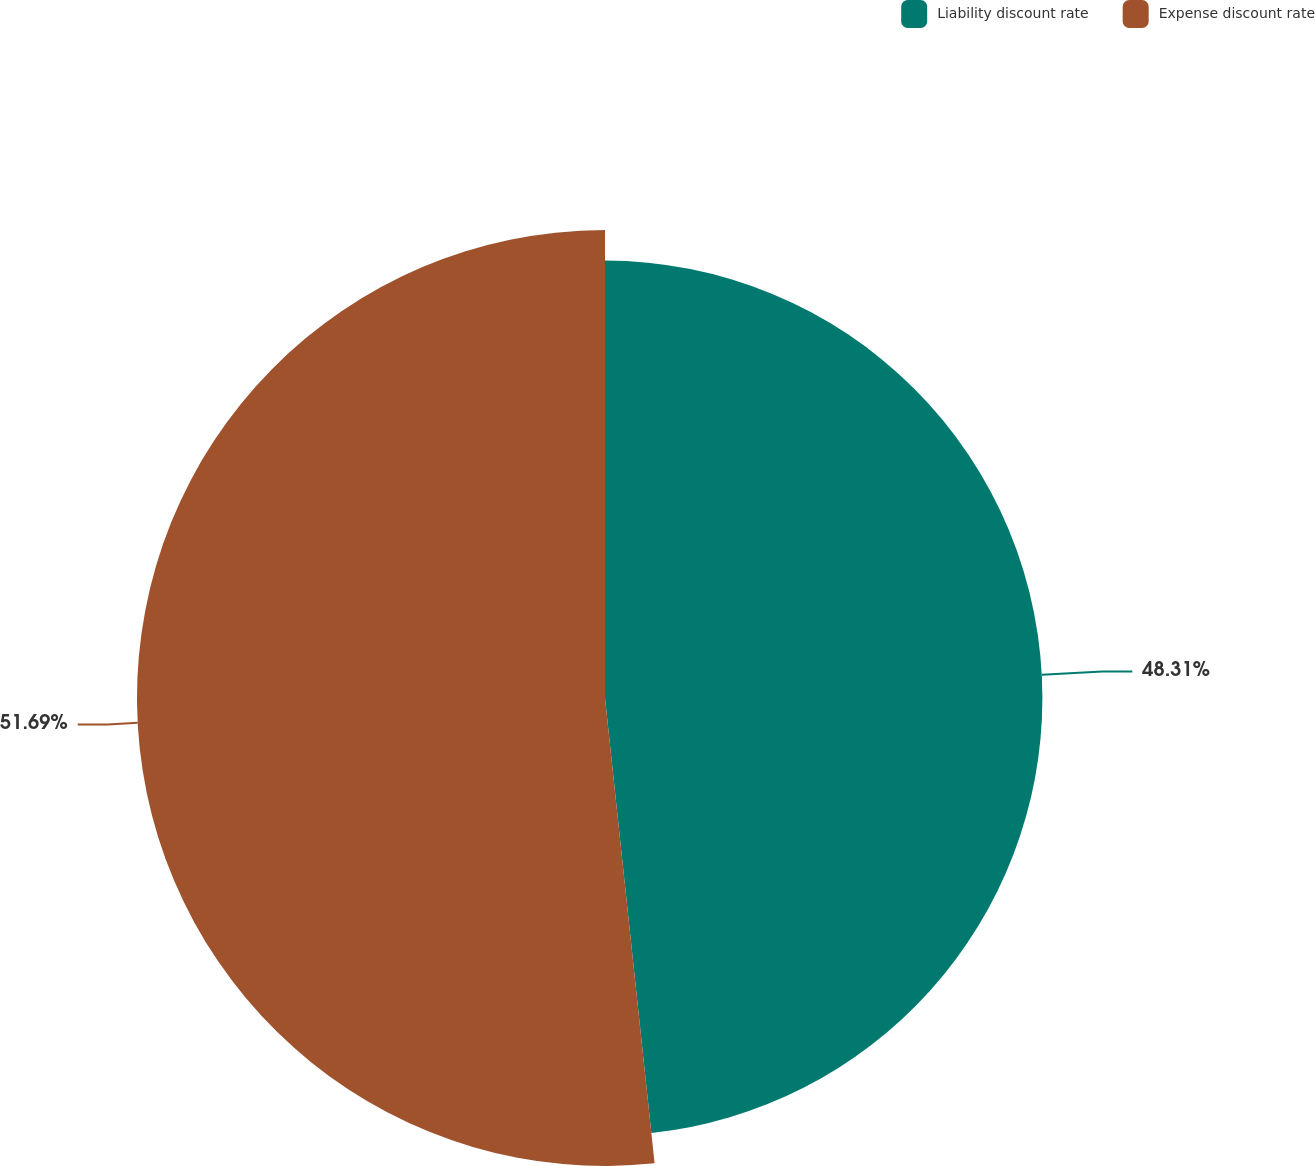<chart> <loc_0><loc_0><loc_500><loc_500><pie_chart><fcel>Liability discount rate<fcel>Expense discount rate<nl><fcel>48.31%<fcel>51.69%<nl></chart> 